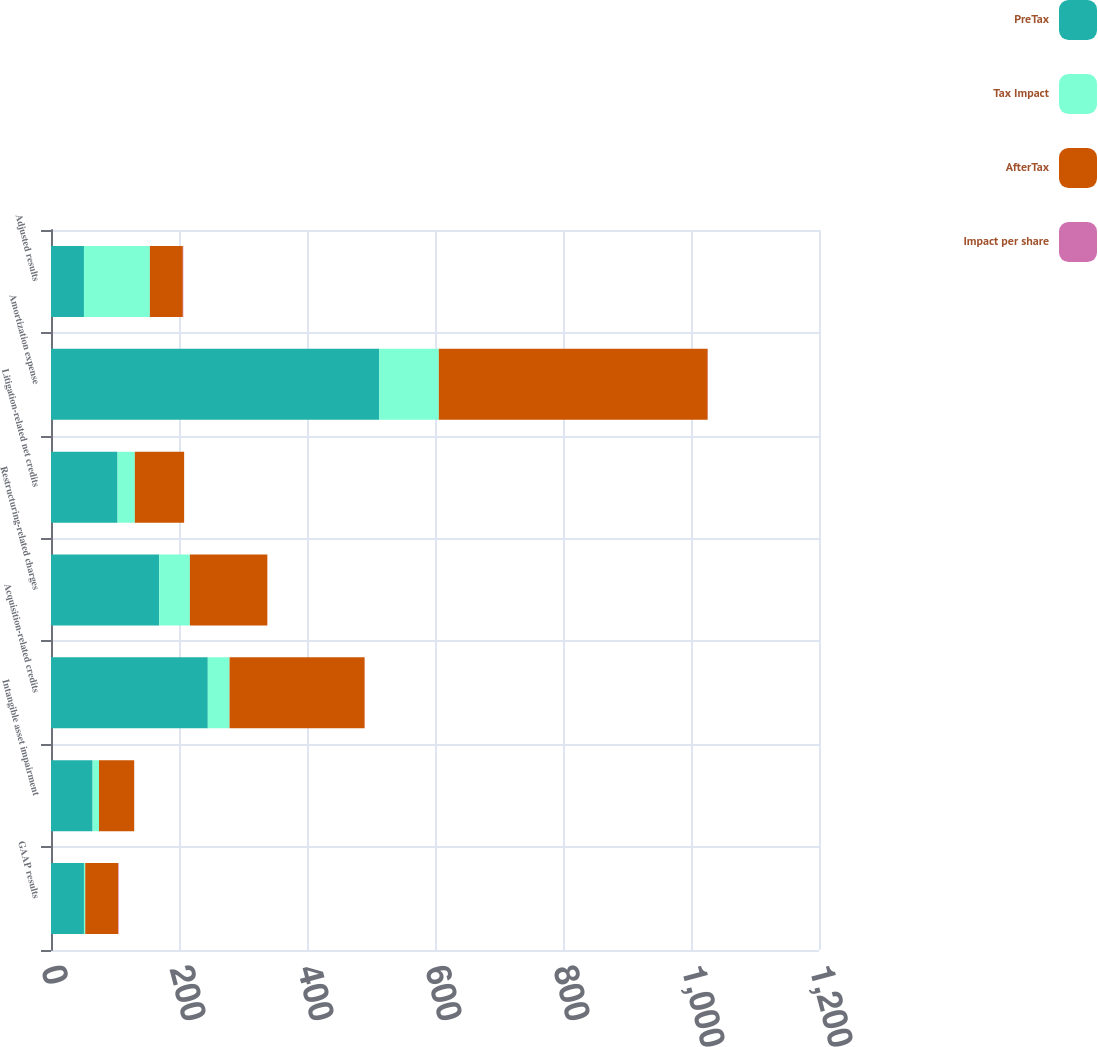Convert chart. <chart><loc_0><loc_0><loc_500><loc_500><stacked_bar_chart><ecel><fcel>GAAP results<fcel>Intangible asset impairment<fcel>Acquisition-related credits<fcel>Restructuring-related charges<fcel>Litigation-related net credits<fcel>Amortization expense<fcel>Adjusted results<nl><fcel>PreTax<fcel>51.5<fcel>65<fcel>245<fcel>169<fcel>104<fcel>513<fcel>51.5<nl><fcel>Tax Impact<fcel>2<fcel>10<fcel>34<fcel>48<fcel>27<fcel>93<fcel>103<nl><fcel>AfterTax<fcel>51.5<fcel>55<fcel>211<fcel>121<fcel>77<fcel>420<fcel>51.5<nl><fcel>Impact per share<fcel>0.7<fcel>0.03<fcel>0.13<fcel>0.08<fcel>0.05<fcel>0.27<fcel>0.69<nl></chart> 